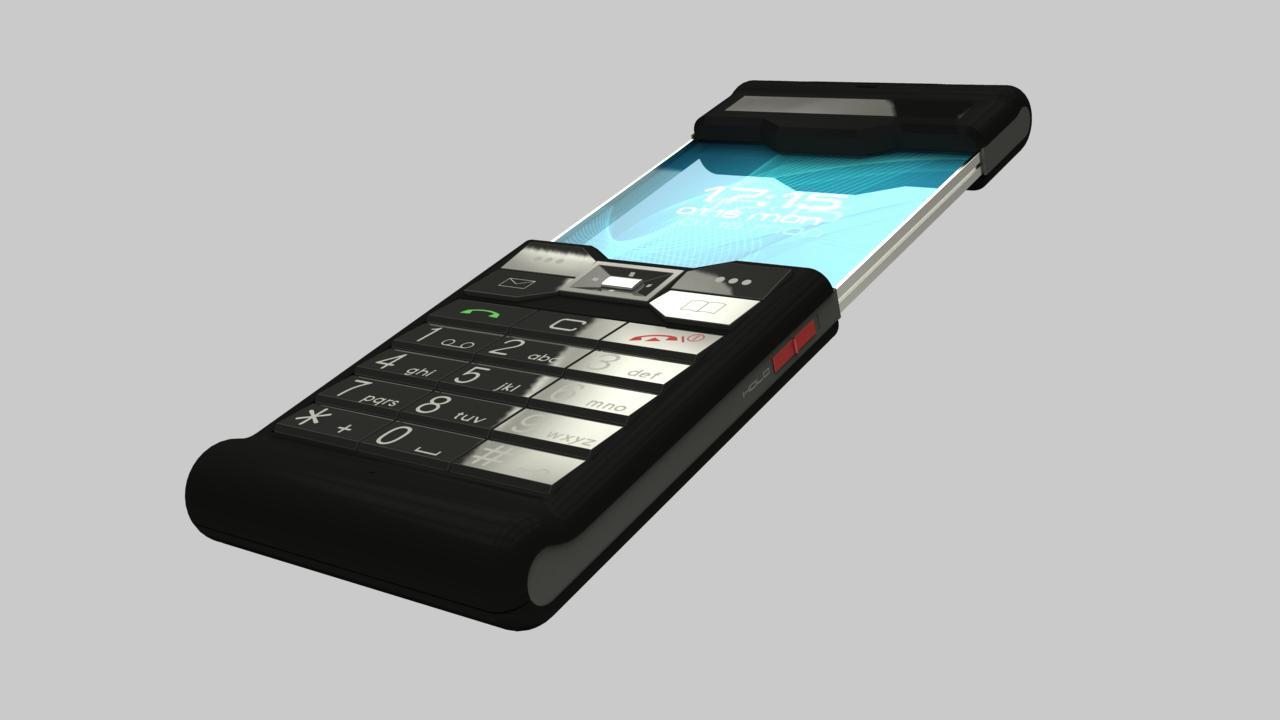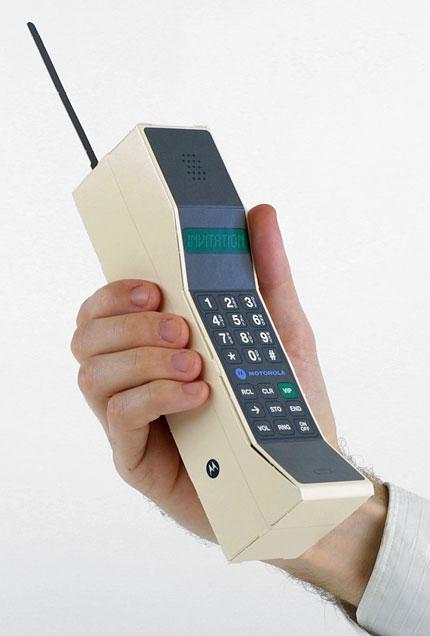The first image is the image on the left, the second image is the image on the right. Analyze the images presented: Is the assertion "There are three objects." valid? Answer yes or no. No. 